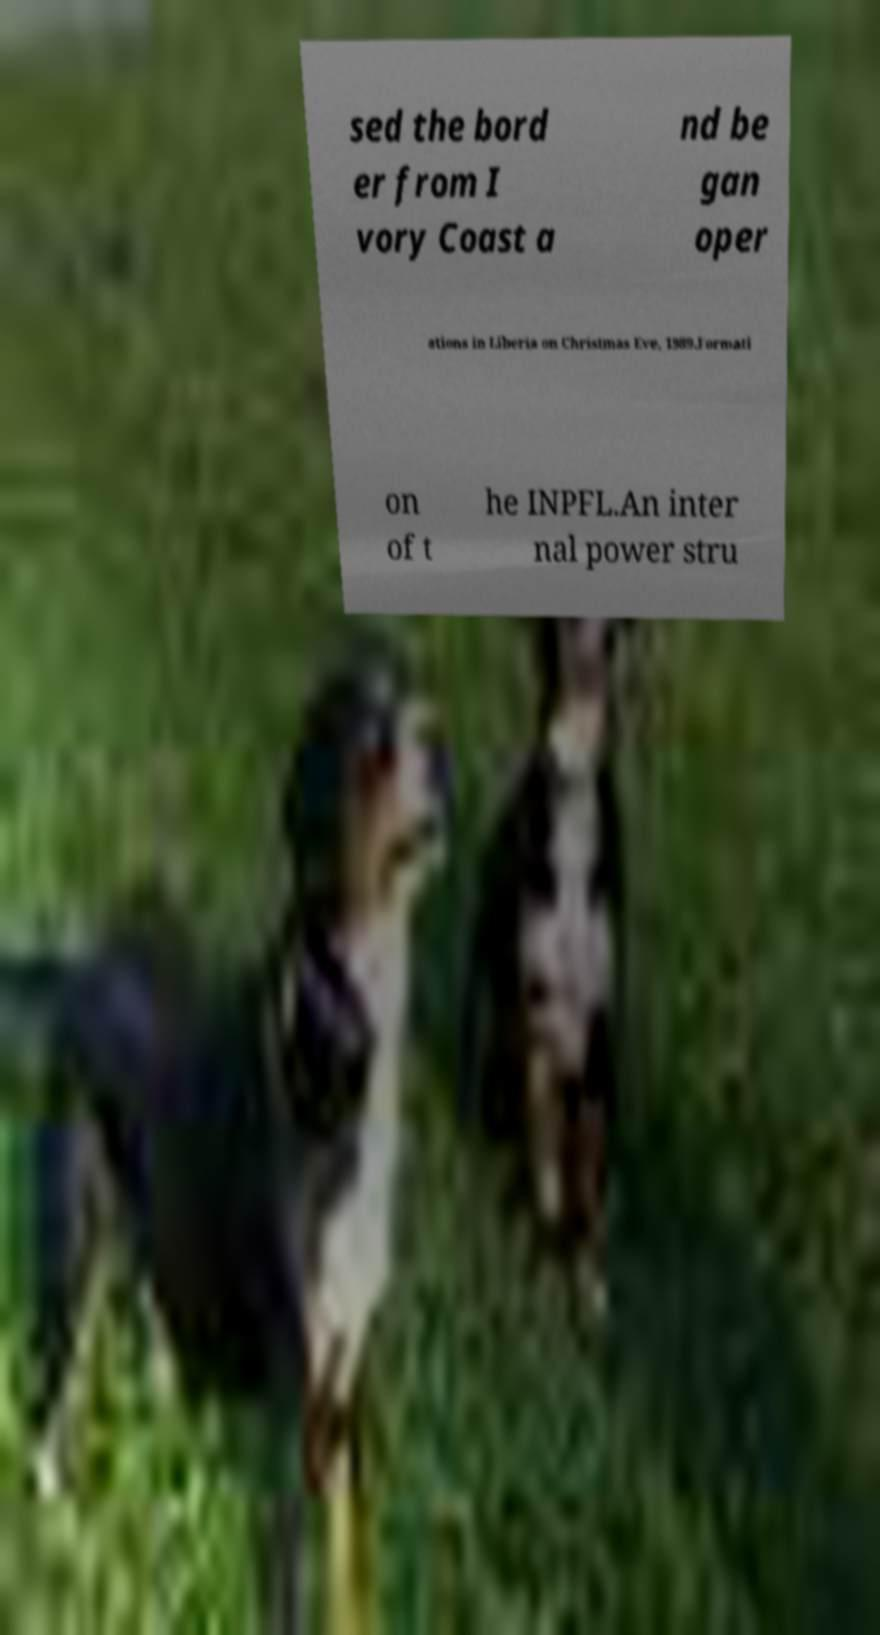Could you extract and type out the text from this image? sed the bord er from I vory Coast a nd be gan oper ations in Liberia on Christmas Eve, 1989.Formati on of t he INPFL.An inter nal power stru 